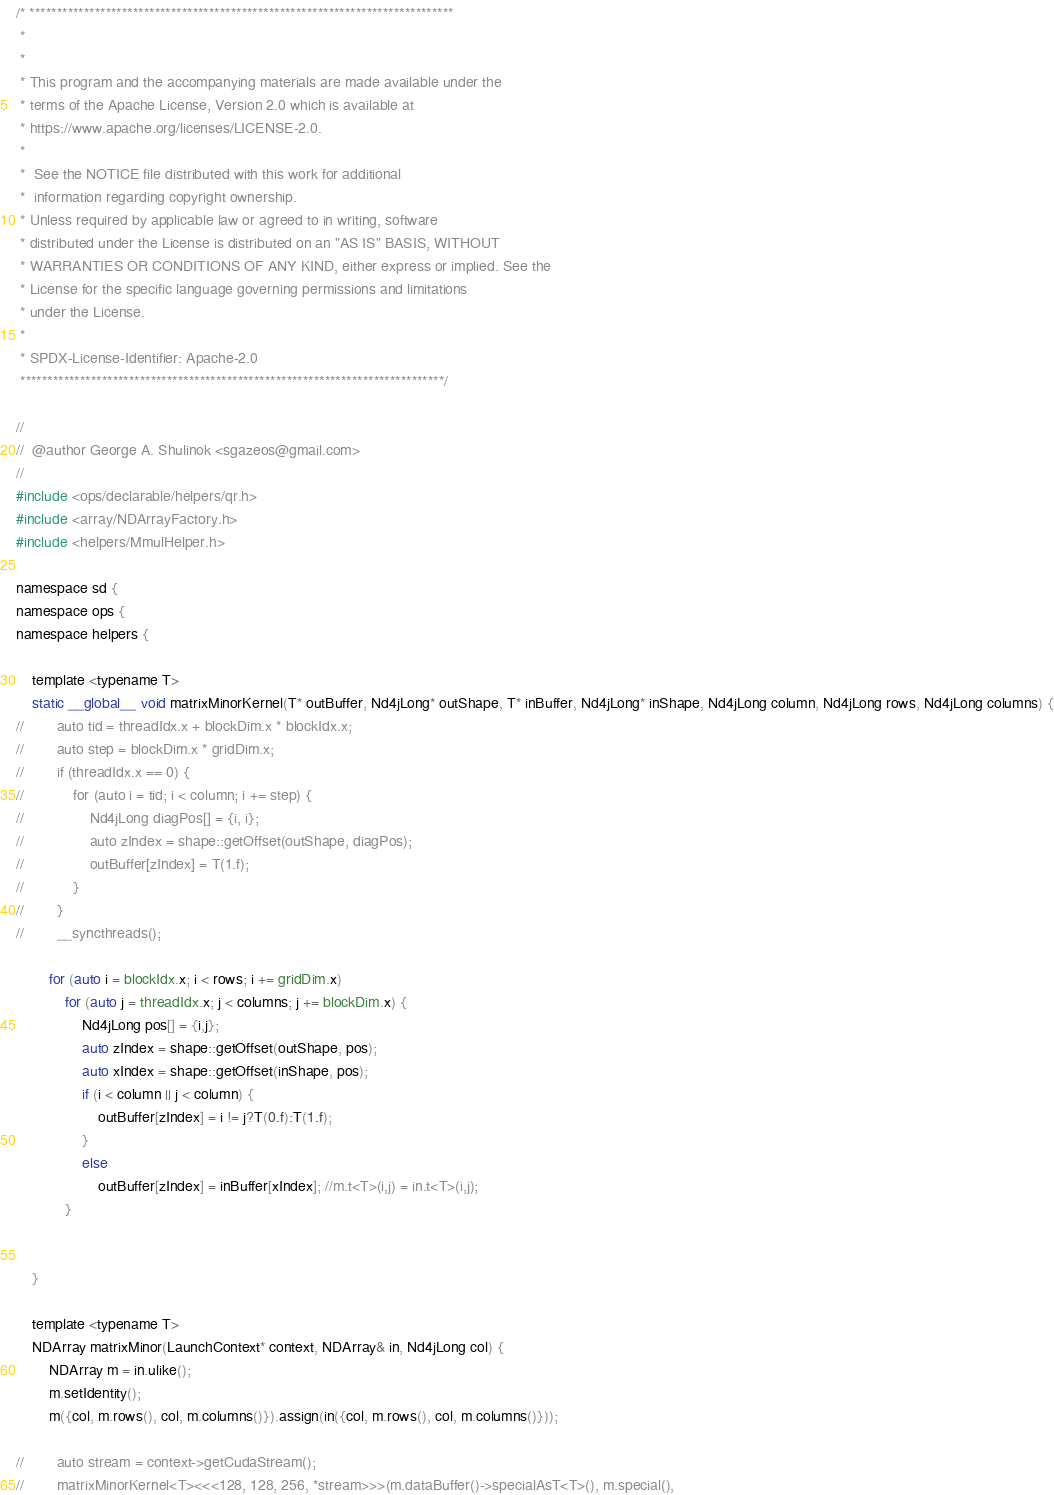<code> <loc_0><loc_0><loc_500><loc_500><_Cuda_>/* ******************************************************************************
 *
 *
 * This program and the accompanying materials are made available under the
 * terms of the Apache License, Version 2.0 which is available at
 * https://www.apache.org/licenses/LICENSE-2.0.
 *
 *  See the NOTICE file distributed with this work for additional
 *  information regarding copyright ownership.
 * Unless required by applicable law or agreed to in writing, software
 * distributed under the License is distributed on an "AS IS" BASIS, WITHOUT
 * WARRANTIES OR CONDITIONS OF ANY KIND, either express or implied. See the
 * License for the specific language governing permissions and limitations
 * under the License.
 *
 * SPDX-License-Identifier: Apache-2.0
 ******************************************************************************/

//
//  @author George A. Shulinok <sgazeos@gmail.com>
//
#include <ops/declarable/helpers/qr.h>
#include <array/NDArrayFactory.h>
#include <helpers/MmulHelper.h>

namespace sd {
namespace ops {
namespace helpers {

    template <typename T>
    static __global__ void matrixMinorKernel(T* outBuffer, Nd4jLong* outShape, T* inBuffer, Nd4jLong* inShape, Nd4jLong column, Nd4jLong rows, Nd4jLong columns) {
//        auto tid = threadIdx.x + blockDim.x * blockIdx.x;
//        auto step = blockDim.x * gridDim.x;
//        if (threadIdx.x == 0) {
//            for (auto i = tid; i < column; i += step) {
//                Nd4jLong diagPos[] = {i, i};
//                auto zIndex = shape::getOffset(outShape, diagPos);
//                outBuffer[zIndex] = T(1.f);
//            }
//        }
//        __syncthreads();

        for (auto i = blockIdx.x; i < rows; i += gridDim.x)
            for (auto j = threadIdx.x; j < columns; j += blockDim.x) {
                Nd4jLong pos[] = {i,j};
                auto zIndex = shape::getOffset(outShape, pos);
                auto xIndex = shape::getOffset(inShape, pos);
                if (i < column || j < column) {
                    outBuffer[zIndex] = i != j?T(0.f):T(1.f);
                }
                else
                    outBuffer[zIndex] = inBuffer[xIndex]; //m.t<T>(i,j) = in.t<T>(i,j);
            }


    }

    template <typename T>
    NDArray matrixMinor(LaunchContext* context, NDArray& in, Nd4jLong col) {
        NDArray m = in.ulike();
        m.setIdentity();
        m({col, m.rows(), col, m.columns()}).assign(in({col, m.rows(), col, m.columns()}));

//        auto stream = context->getCudaStream();
//        matrixMinorKernel<T><<<128, 128, 256, *stream>>>(m.dataBuffer()->specialAsT<T>(), m.special(),</code> 